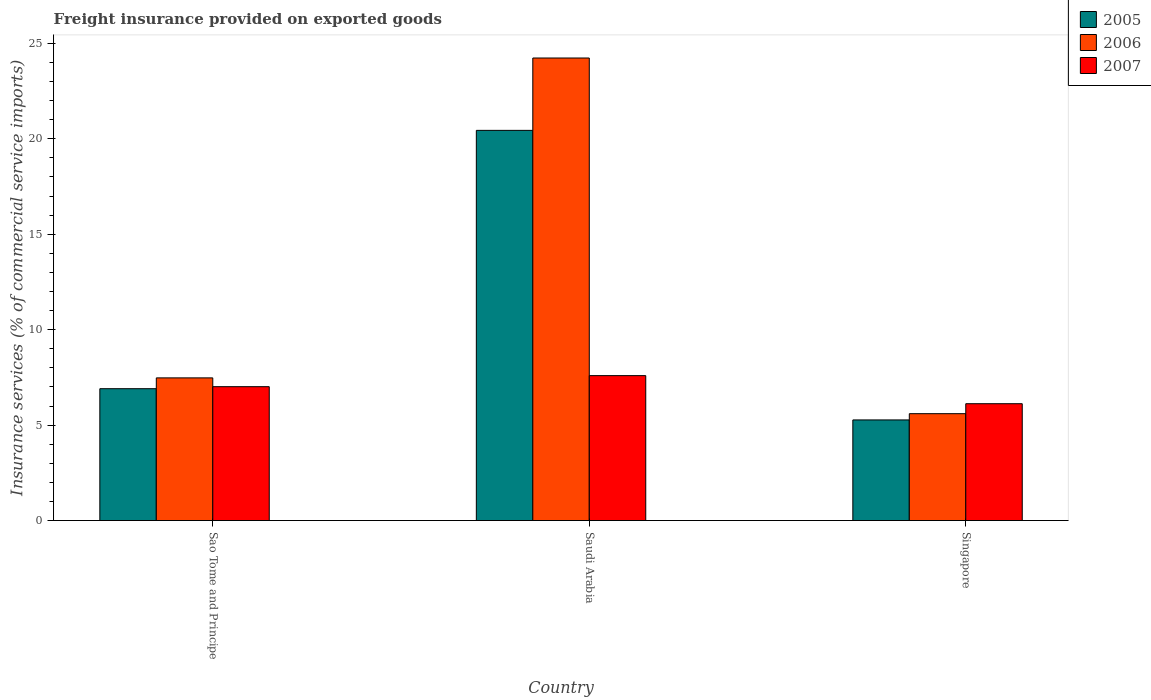What is the label of the 1st group of bars from the left?
Keep it short and to the point. Sao Tome and Principe. What is the freight insurance provided on exported goods in 2007 in Singapore?
Keep it short and to the point. 6.12. Across all countries, what is the maximum freight insurance provided on exported goods in 2006?
Your response must be concise. 24.23. Across all countries, what is the minimum freight insurance provided on exported goods in 2005?
Make the answer very short. 5.27. In which country was the freight insurance provided on exported goods in 2005 maximum?
Provide a short and direct response. Saudi Arabia. In which country was the freight insurance provided on exported goods in 2005 minimum?
Give a very brief answer. Singapore. What is the total freight insurance provided on exported goods in 2005 in the graph?
Offer a very short reply. 32.62. What is the difference between the freight insurance provided on exported goods in 2005 in Sao Tome and Principe and that in Singapore?
Keep it short and to the point. 1.64. What is the difference between the freight insurance provided on exported goods in 2005 in Sao Tome and Principe and the freight insurance provided on exported goods in 2006 in Saudi Arabia?
Give a very brief answer. -17.32. What is the average freight insurance provided on exported goods in 2007 per country?
Provide a short and direct response. 6.91. What is the difference between the freight insurance provided on exported goods of/in 2006 and freight insurance provided on exported goods of/in 2005 in Singapore?
Make the answer very short. 0.33. In how many countries, is the freight insurance provided on exported goods in 2006 greater than 12 %?
Make the answer very short. 1. What is the ratio of the freight insurance provided on exported goods in 2005 in Sao Tome and Principe to that in Singapore?
Your response must be concise. 1.31. What is the difference between the highest and the second highest freight insurance provided on exported goods in 2007?
Offer a terse response. 0.89. What is the difference between the highest and the lowest freight insurance provided on exported goods in 2006?
Provide a short and direct response. 18.63. What does the 1st bar from the left in Saudi Arabia represents?
Provide a short and direct response. 2005. Is it the case that in every country, the sum of the freight insurance provided on exported goods in 2007 and freight insurance provided on exported goods in 2006 is greater than the freight insurance provided on exported goods in 2005?
Offer a very short reply. Yes. Are all the bars in the graph horizontal?
Give a very brief answer. No. What is the difference between two consecutive major ticks on the Y-axis?
Ensure brevity in your answer.  5. Are the values on the major ticks of Y-axis written in scientific E-notation?
Give a very brief answer. No. How many legend labels are there?
Keep it short and to the point. 3. How are the legend labels stacked?
Offer a terse response. Vertical. What is the title of the graph?
Ensure brevity in your answer.  Freight insurance provided on exported goods. Does "2007" appear as one of the legend labels in the graph?
Your answer should be compact. Yes. What is the label or title of the X-axis?
Provide a short and direct response. Country. What is the label or title of the Y-axis?
Keep it short and to the point. Insurance services (% of commercial service imports). What is the Insurance services (% of commercial service imports) of 2005 in Sao Tome and Principe?
Offer a very short reply. 6.91. What is the Insurance services (% of commercial service imports) in 2006 in Sao Tome and Principe?
Give a very brief answer. 7.48. What is the Insurance services (% of commercial service imports) in 2007 in Sao Tome and Principe?
Give a very brief answer. 7.01. What is the Insurance services (% of commercial service imports) in 2005 in Saudi Arabia?
Offer a terse response. 20.44. What is the Insurance services (% of commercial service imports) in 2006 in Saudi Arabia?
Ensure brevity in your answer.  24.23. What is the Insurance services (% of commercial service imports) of 2007 in Saudi Arabia?
Your answer should be compact. 7.59. What is the Insurance services (% of commercial service imports) in 2005 in Singapore?
Provide a short and direct response. 5.27. What is the Insurance services (% of commercial service imports) in 2006 in Singapore?
Offer a terse response. 5.6. What is the Insurance services (% of commercial service imports) of 2007 in Singapore?
Keep it short and to the point. 6.12. Across all countries, what is the maximum Insurance services (% of commercial service imports) of 2005?
Your answer should be compact. 20.44. Across all countries, what is the maximum Insurance services (% of commercial service imports) of 2006?
Your response must be concise. 24.23. Across all countries, what is the maximum Insurance services (% of commercial service imports) in 2007?
Provide a succinct answer. 7.59. Across all countries, what is the minimum Insurance services (% of commercial service imports) in 2005?
Make the answer very short. 5.27. Across all countries, what is the minimum Insurance services (% of commercial service imports) in 2006?
Keep it short and to the point. 5.6. Across all countries, what is the minimum Insurance services (% of commercial service imports) in 2007?
Your answer should be compact. 6.12. What is the total Insurance services (% of commercial service imports) of 2005 in the graph?
Provide a short and direct response. 32.62. What is the total Insurance services (% of commercial service imports) in 2006 in the graph?
Your response must be concise. 37.31. What is the total Insurance services (% of commercial service imports) of 2007 in the graph?
Give a very brief answer. 20.73. What is the difference between the Insurance services (% of commercial service imports) in 2005 in Sao Tome and Principe and that in Saudi Arabia?
Your answer should be compact. -13.53. What is the difference between the Insurance services (% of commercial service imports) of 2006 in Sao Tome and Principe and that in Saudi Arabia?
Ensure brevity in your answer.  -16.76. What is the difference between the Insurance services (% of commercial service imports) of 2007 in Sao Tome and Principe and that in Saudi Arabia?
Your answer should be very brief. -0.58. What is the difference between the Insurance services (% of commercial service imports) of 2005 in Sao Tome and Principe and that in Singapore?
Keep it short and to the point. 1.64. What is the difference between the Insurance services (% of commercial service imports) in 2006 in Sao Tome and Principe and that in Singapore?
Make the answer very short. 1.88. What is the difference between the Insurance services (% of commercial service imports) in 2007 in Sao Tome and Principe and that in Singapore?
Offer a very short reply. 0.89. What is the difference between the Insurance services (% of commercial service imports) of 2005 in Saudi Arabia and that in Singapore?
Your answer should be compact. 15.17. What is the difference between the Insurance services (% of commercial service imports) of 2006 in Saudi Arabia and that in Singapore?
Offer a very short reply. 18.63. What is the difference between the Insurance services (% of commercial service imports) in 2007 in Saudi Arabia and that in Singapore?
Provide a succinct answer. 1.47. What is the difference between the Insurance services (% of commercial service imports) of 2005 in Sao Tome and Principe and the Insurance services (% of commercial service imports) of 2006 in Saudi Arabia?
Your answer should be very brief. -17.32. What is the difference between the Insurance services (% of commercial service imports) in 2005 in Sao Tome and Principe and the Insurance services (% of commercial service imports) in 2007 in Saudi Arabia?
Make the answer very short. -0.68. What is the difference between the Insurance services (% of commercial service imports) in 2006 in Sao Tome and Principe and the Insurance services (% of commercial service imports) in 2007 in Saudi Arabia?
Provide a succinct answer. -0.12. What is the difference between the Insurance services (% of commercial service imports) of 2005 in Sao Tome and Principe and the Insurance services (% of commercial service imports) of 2006 in Singapore?
Offer a very short reply. 1.31. What is the difference between the Insurance services (% of commercial service imports) in 2005 in Sao Tome and Principe and the Insurance services (% of commercial service imports) in 2007 in Singapore?
Keep it short and to the point. 0.79. What is the difference between the Insurance services (% of commercial service imports) of 2006 in Sao Tome and Principe and the Insurance services (% of commercial service imports) of 2007 in Singapore?
Provide a succinct answer. 1.35. What is the difference between the Insurance services (% of commercial service imports) of 2005 in Saudi Arabia and the Insurance services (% of commercial service imports) of 2006 in Singapore?
Keep it short and to the point. 14.84. What is the difference between the Insurance services (% of commercial service imports) of 2005 in Saudi Arabia and the Insurance services (% of commercial service imports) of 2007 in Singapore?
Your response must be concise. 14.32. What is the difference between the Insurance services (% of commercial service imports) of 2006 in Saudi Arabia and the Insurance services (% of commercial service imports) of 2007 in Singapore?
Your response must be concise. 18.11. What is the average Insurance services (% of commercial service imports) of 2005 per country?
Keep it short and to the point. 10.87. What is the average Insurance services (% of commercial service imports) in 2006 per country?
Your response must be concise. 12.44. What is the average Insurance services (% of commercial service imports) in 2007 per country?
Provide a succinct answer. 6.91. What is the difference between the Insurance services (% of commercial service imports) in 2005 and Insurance services (% of commercial service imports) in 2006 in Sao Tome and Principe?
Provide a short and direct response. -0.57. What is the difference between the Insurance services (% of commercial service imports) of 2005 and Insurance services (% of commercial service imports) of 2007 in Sao Tome and Principe?
Your response must be concise. -0.11. What is the difference between the Insurance services (% of commercial service imports) in 2006 and Insurance services (% of commercial service imports) in 2007 in Sao Tome and Principe?
Give a very brief answer. 0.46. What is the difference between the Insurance services (% of commercial service imports) of 2005 and Insurance services (% of commercial service imports) of 2006 in Saudi Arabia?
Provide a succinct answer. -3.79. What is the difference between the Insurance services (% of commercial service imports) of 2005 and Insurance services (% of commercial service imports) of 2007 in Saudi Arabia?
Provide a short and direct response. 12.85. What is the difference between the Insurance services (% of commercial service imports) in 2006 and Insurance services (% of commercial service imports) in 2007 in Saudi Arabia?
Give a very brief answer. 16.64. What is the difference between the Insurance services (% of commercial service imports) in 2005 and Insurance services (% of commercial service imports) in 2006 in Singapore?
Keep it short and to the point. -0.33. What is the difference between the Insurance services (% of commercial service imports) of 2005 and Insurance services (% of commercial service imports) of 2007 in Singapore?
Offer a terse response. -0.85. What is the difference between the Insurance services (% of commercial service imports) of 2006 and Insurance services (% of commercial service imports) of 2007 in Singapore?
Provide a succinct answer. -0.52. What is the ratio of the Insurance services (% of commercial service imports) of 2005 in Sao Tome and Principe to that in Saudi Arabia?
Your response must be concise. 0.34. What is the ratio of the Insurance services (% of commercial service imports) in 2006 in Sao Tome and Principe to that in Saudi Arabia?
Give a very brief answer. 0.31. What is the ratio of the Insurance services (% of commercial service imports) of 2007 in Sao Tome and Principe to that in Saudi Arabia?
Your answer should be very brief. 0.92. What is the ratio of the Insurance services (% of commercial service imports) in 2005 in Sao Tome and Principe to that in Singapore?
Your answer should be very brief. 1.31. What is the ratio of the Insurance services (% of commercial service imports) in 2006 in Sao Tome and Principe to that in Singapore?
Provide a succinct answer. 1.33. What is the ratio of the Insurance services (% of commercial service imports) of 2007 in Sao Tome and Principe to that in Singapore?
Your answer should be very brief. 1.15. What is the ratio of the Insurance services (% of commercial service imports) in 2005 in Saudi Arabia to that in Singapore?
Offer a very short reply. 3.88. What is the ratio of the Insurance services (% of commercial service imports) in 2006 in Saudi Arabia to that in Singapore?
Provide a short and direct response. 4.33. What is the ratio of the Insurance services (% of commercial service imports) of 2007 in Saudi Arabia to that in Singapore?
Provide a short and direct response. 1.24. What is the difference between the highest and the second highest Insurance services (% of commercial service imports) in 2005?
Offer a terse response. 13.53. What is the difference between the highest and the second highest Insurance services (% of commercial service imports) in 2006?
Ensure brevity in your answer.  16.76. What is the difference between the highest and the second highest Insurance services (% of commercial service imports) of 2007?
Provide a short and direct response. 0.58. What is the difference between the highest and the lowest Insurance services (% of commercial service imports) of 2005?
Provide a succinct answer. 15.17. What is the difference between the highest and the lowest Insurance services (% of commercial service imports) of 2006?
Your response must be concise. 18.63. What is the difference between the highest and the lowest Insurance services (% of commercial service imports) of 2007?
Keep it short and to the point. 1.47. 